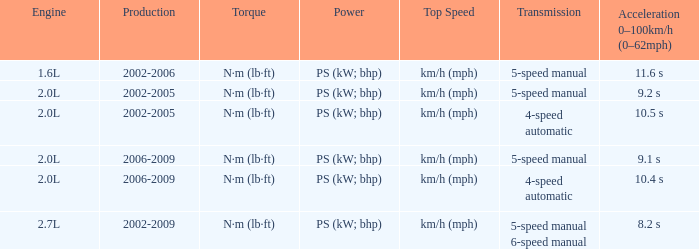What is the top speed of a 4-speed automatic with production in 2002-2005? Km/h (mph). 